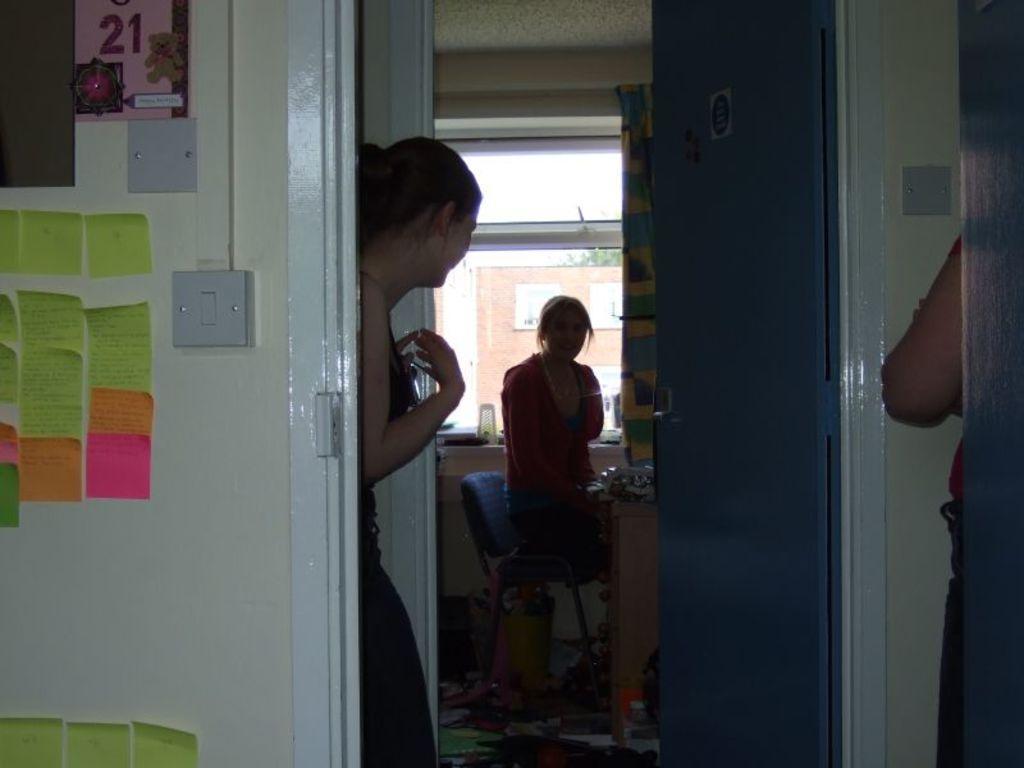How would you summarize this image in a sentence or two? On the left side, there are posters pasted on the wall. Beside this wall, there is a woman standing. On the right side, there is a person standing. Beside this person, there is a door. In the background, there is a woman. Beside her, there is a table on which, there are some objects, there is a window and there are other objects. 